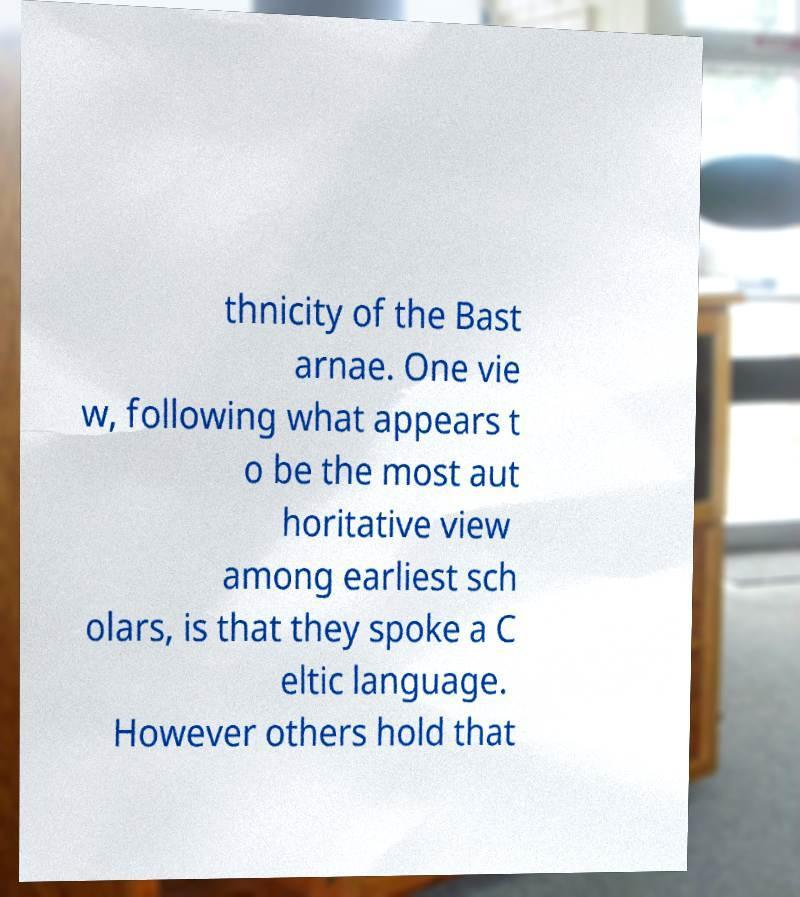There's text embedded in this image that I need extracted. Can you transcribe it verbatim? thnicity of the Bast arnae. One vie w, following what appears t o be the most aut horitative view among earliest sch olars, is that they spoke a C eltic language. However others hold that 